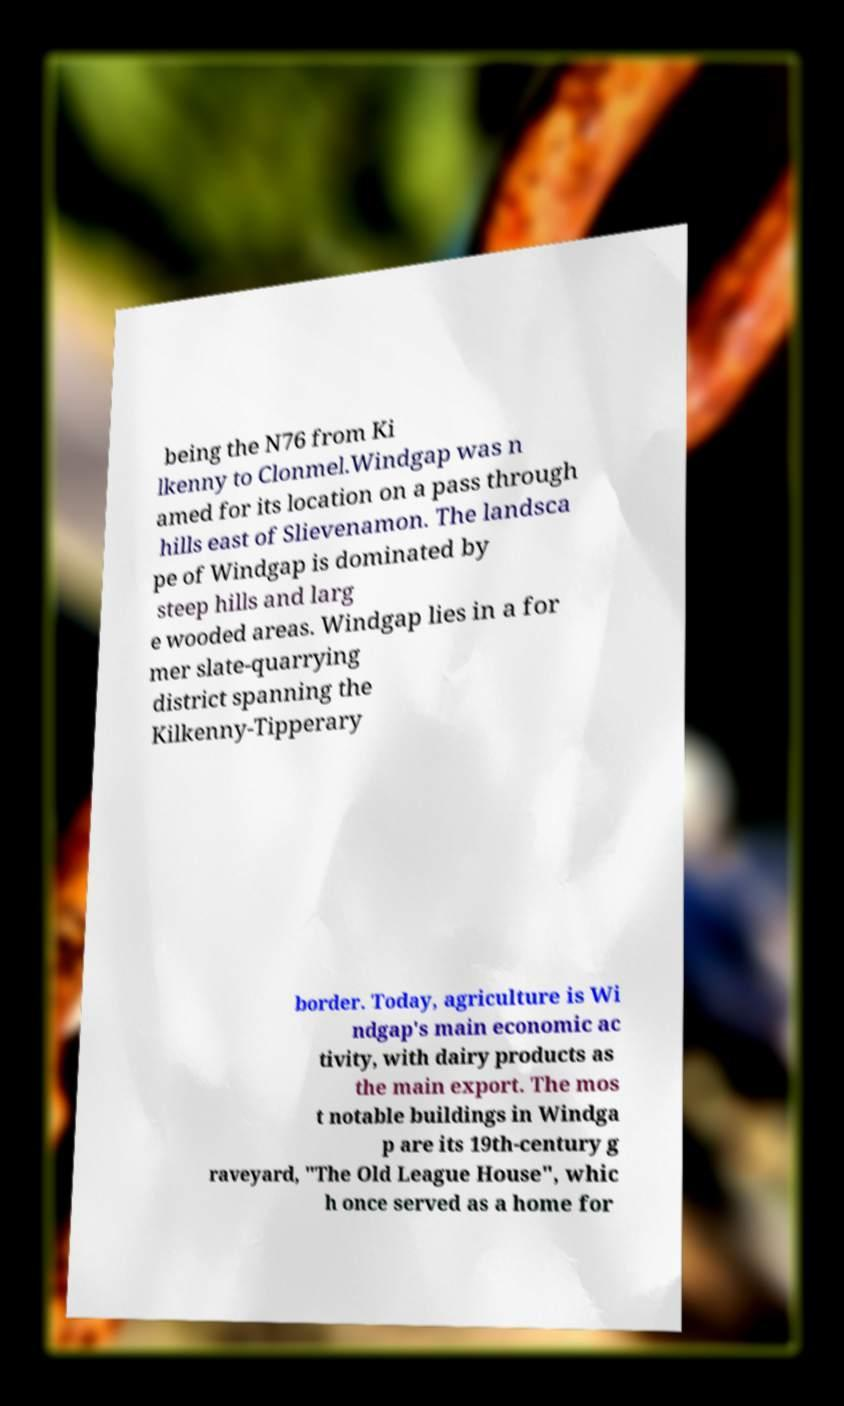For documentation purposes, I need the text within this image transcribed. Could you provide that? being the N76 from Ki lkenny to Clonmel.Windgap was n amed for its location on a pass through hills east of Slievenamon. The landsca pe of Windgap is dominated by steep hills and larg e wooded areas. Windgap lies in a for mer slate-quarrying district spanning the Kilkenny-Tipperary border. Today, agriculture is Wi ndgap's main economic ac tivity, with dairy products as the main export. The mos t notable buildings in Windga p are its 19th-century g raveyard, "The Old League House", whic h once served as a home for 